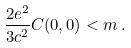Convert formula to latex. <formula><loc_0><loc_0><loc_500><loc_500>\frac { 2 e ^ { 2 } } { 3 c ^ { 2 } } C ( 0 , 0 ) < m \, .</formula> 